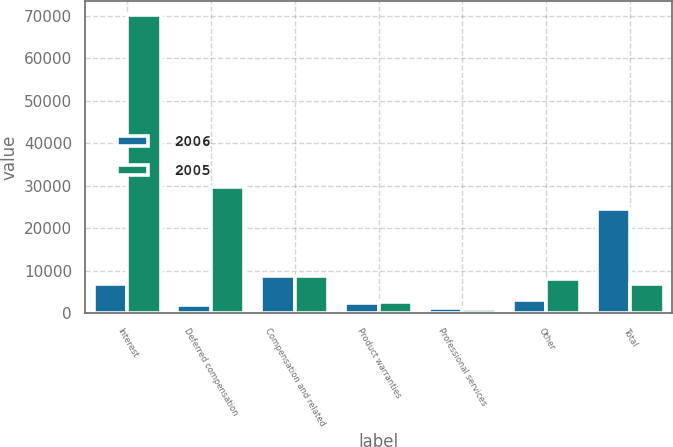<chart> <loc_0><loc_0><loc_500><loc_500><stacked_bar_chart><ecel><fcel>Interest<fcel>Deferred compensation<fcel>Compensation and related<fcel>Product warranties<fcel>Professional services<fcel>Other<fcel>Total<nl><fcel>2006<fcel>6913<fcel>1888<fcel>8831<fcel>2472<fcel>1373<fcel>3198<fcel>24675<nl><fcel>2005<fcel>70109<fcel>29736<fcel>8858<fcel>2789<fcel>940<fcel>7993<fcel>6913<nl></chart> 